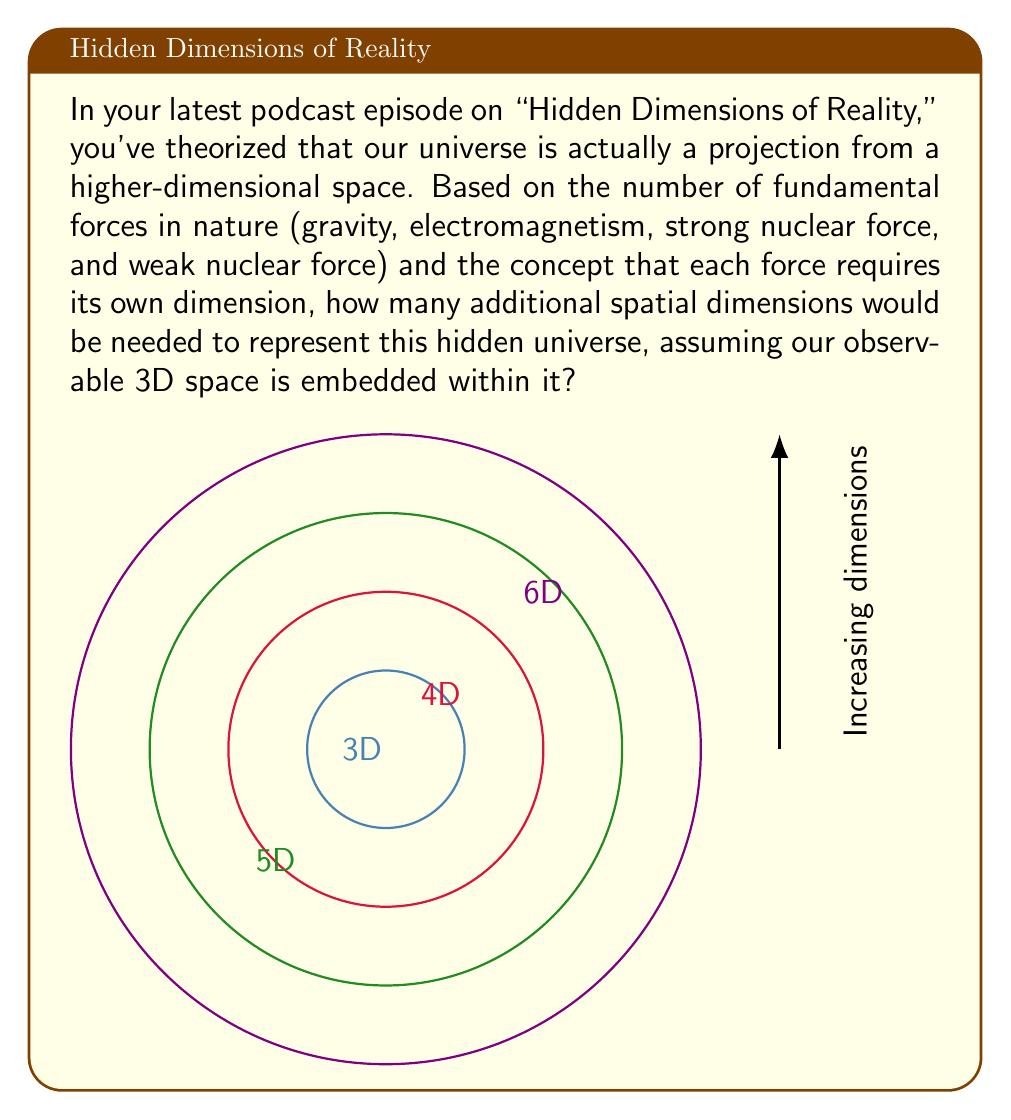Can you solve this math problem? To solve this problem, we need to follow these steps:

1) First, we consider our observable universe, which has 3 spatial dimensions: length, width, and height. Let's denote this as:

   $D_{observable} = 3$

2) Now, we need to account for the fundamental forces. In standard physics, there are four fundamental forces:
   - Gravity
   - Electromagnetism
   - Strong nuclear force
   - Weak nuclear force

3) According to the theory presented in the podcast, each force requires its own dimension. So we need to add 4 more dimensions:

   $D_{forces} = 4$

4) To calculate the total number of dimensions in the hidden universe, we add the observable dimensions and the force dimensions:

   $D_{total} = D_{observable} + D_{forces}$
   $D_{total} = 3 + 4 = 7$

5) Finally, to find the number of additional spatial dimensions, we subtract the observable dimensions from the total:

   $D_{additional} = D_{total} - D_{observable}$
   $D_{additional} = 7 - 3 = 4$

Therefore, according to this theory, 4 additional spatial dimensions would be needed to represent the hidden universe.
Answer: 4 